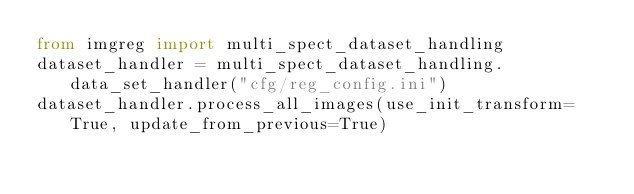Convert code to text. <code><loc_0><loc_0><loc_500><loc_500><_Python_>from imgreg import multi_spect_dataset_handling
dataset_handler = multi_spect_dataset_handling.data_set_handler("cfg/reg_config.ini")
dataset_handler.process_all_images(use_init_transform=True, update_from_previous=True)</code> 